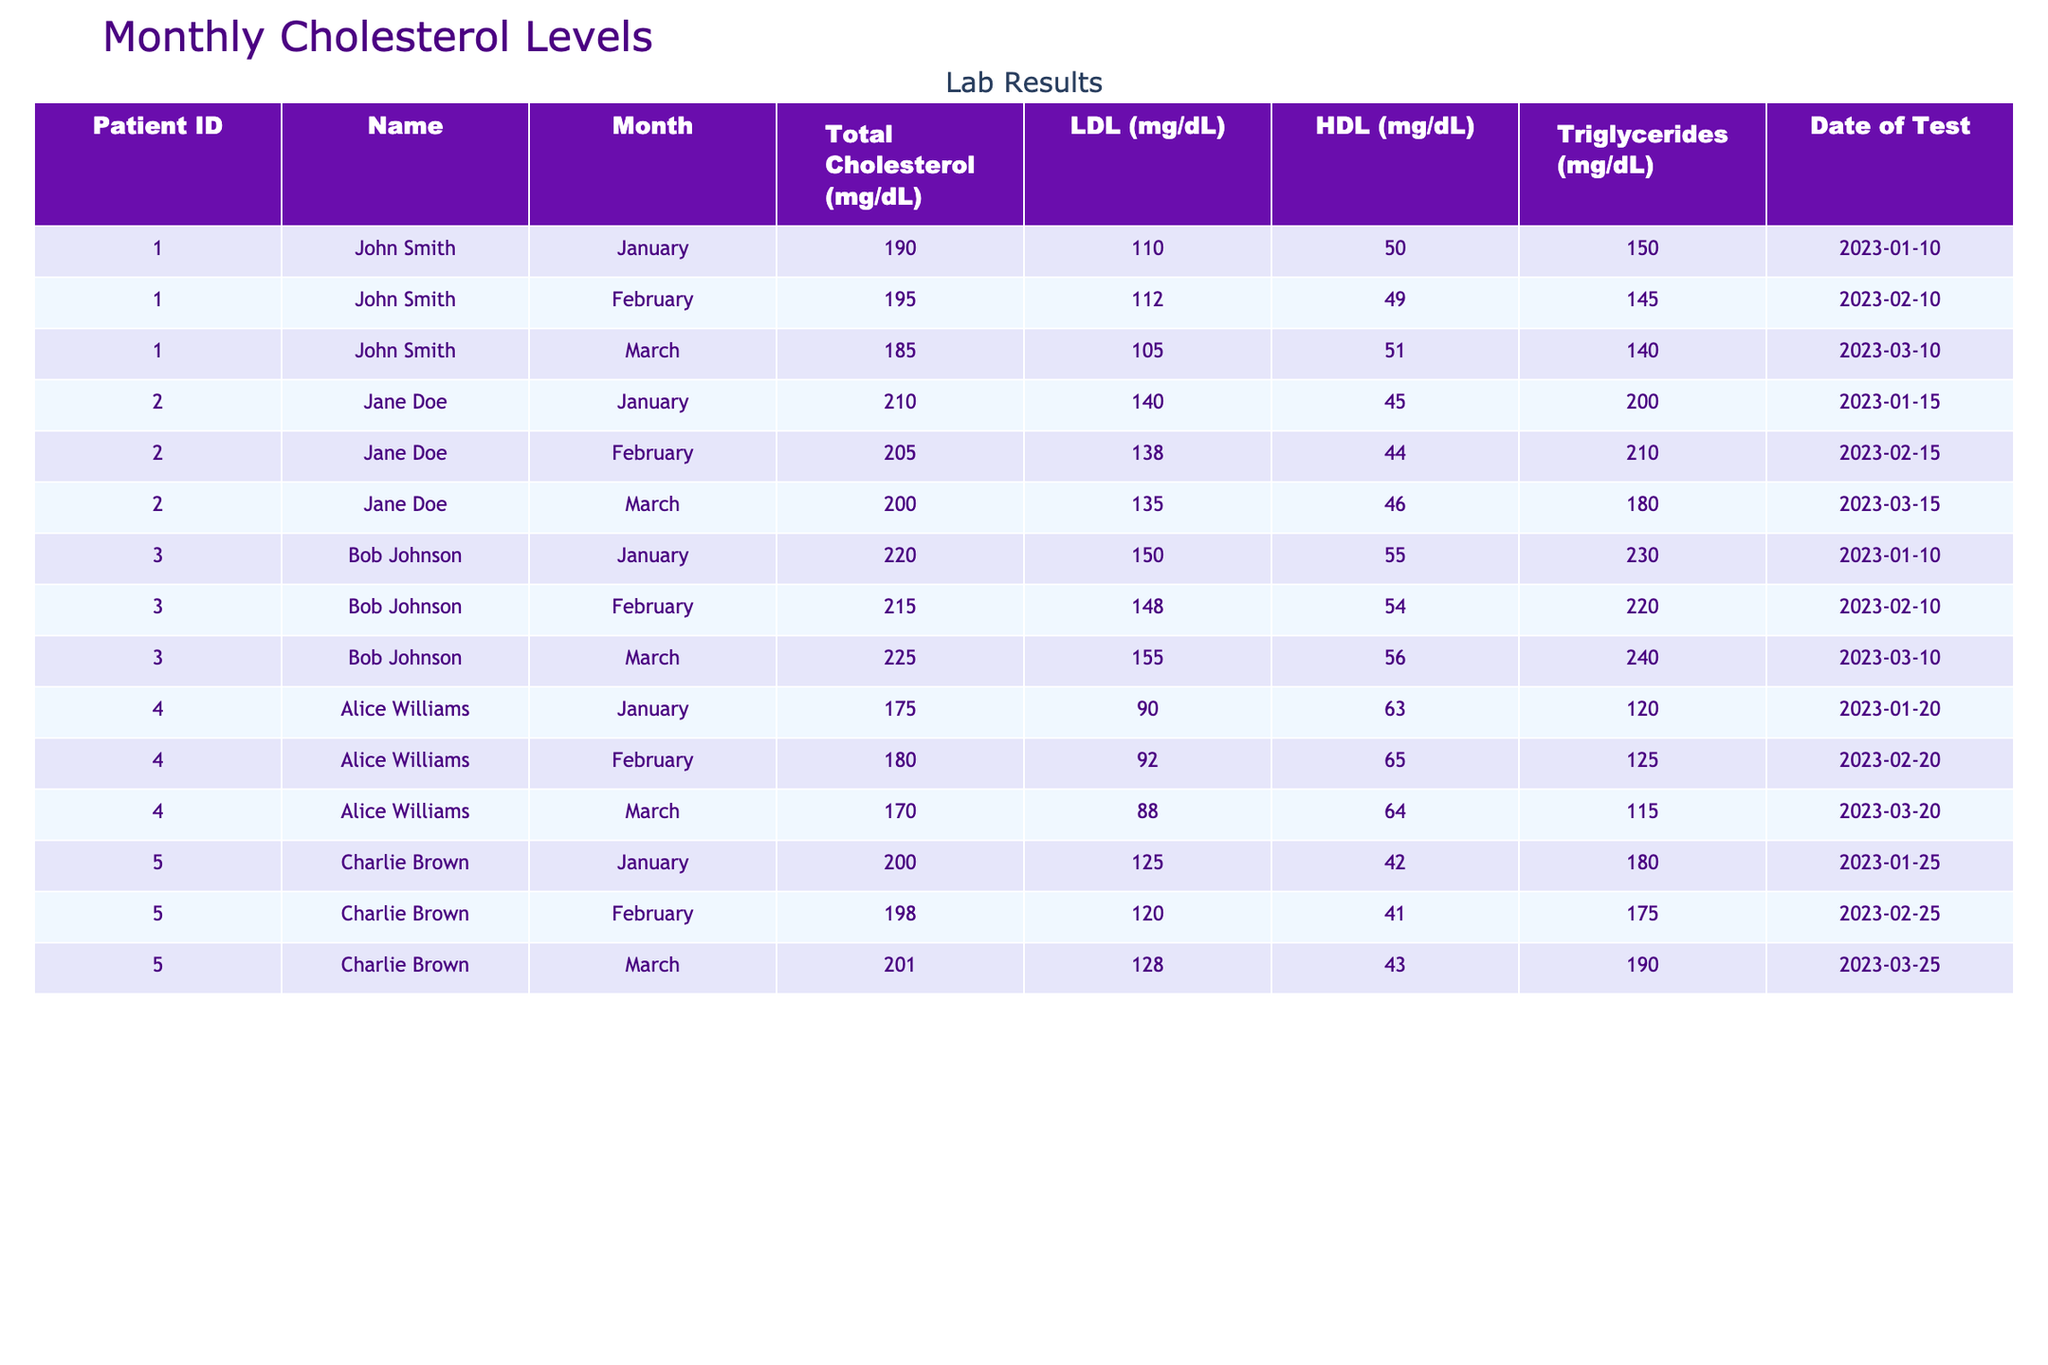What is John Smith's total cholesterol level in March? In the table, I locate John Smith's data for March. His total cholesterol for that month is specifically listed as 185 mg/dL.
Answer: 185 mg/dL Which patient had the highest total cholesterol level in January? Reviewing the January entries for all patients, Bob Johnson recorded the highest total cholesterol level of 220 mg/dL.
Answer: Bob Johnson What was the average LDL level for Jane Doe across the three months? I add Jane Doe's LDL levels across January (140), February (138), and March (135), giving a total of 413. Then, I divide this sum by 3 (the number of months): 413 / 3 = 137.67.
Answer: 137.67 mg/dL Did Alice Williams' total cholesterol level decrease from January to March? I compare Alice's total cholesterol for January (175 mg/dL) with that in March (170 mg/dL). Since 170 is less than 175, her total cholesterol decreased.
Answer: Yes What is the difference in triglyceride levels between Bob Johnson's highest and lowest readings? Bob's highest triglyceride level is in March (240 mg/dL) and the lowest is in January (230 mg/dL). I calculate the difference by subtracting the lowest from the highest: 240 - 230 = 10.
Answer: 10 mg/dL What is the total number of cholesterol tests performed across all patients in February? I check the table for the number of entries listed in February. Each patient has one entry per month, and there are five patients, resulting in a total of 5 tests for February.
Answer: 5 tests What was Charlie Brown's HDL level in February? Looking at Charlie Brown's data for February directly, his HDL level is listed as 41 mg/dL.
Answer: 41 mg/dL Which patient had the most consistent HDL levels over the three months? I analyze the HDL levels for each patient across the three months. For Alice Williams, the levels are 63, 65, and 64 mg/dL, with only a 2 mg/dL difference. This shows her HDL levels were the most consistent compared to others.
Answer: Alice Williams What is the median total cholesterol level for all patients in March? After identifying the total cholesterol levels for March (185, 200, 225, 170, and 201 mg/dL), I arrange them in order (170, 185, 200, 201, 225). The median is the middle value, which is 200 mg/dL.
Answer: 200 mg/dL 